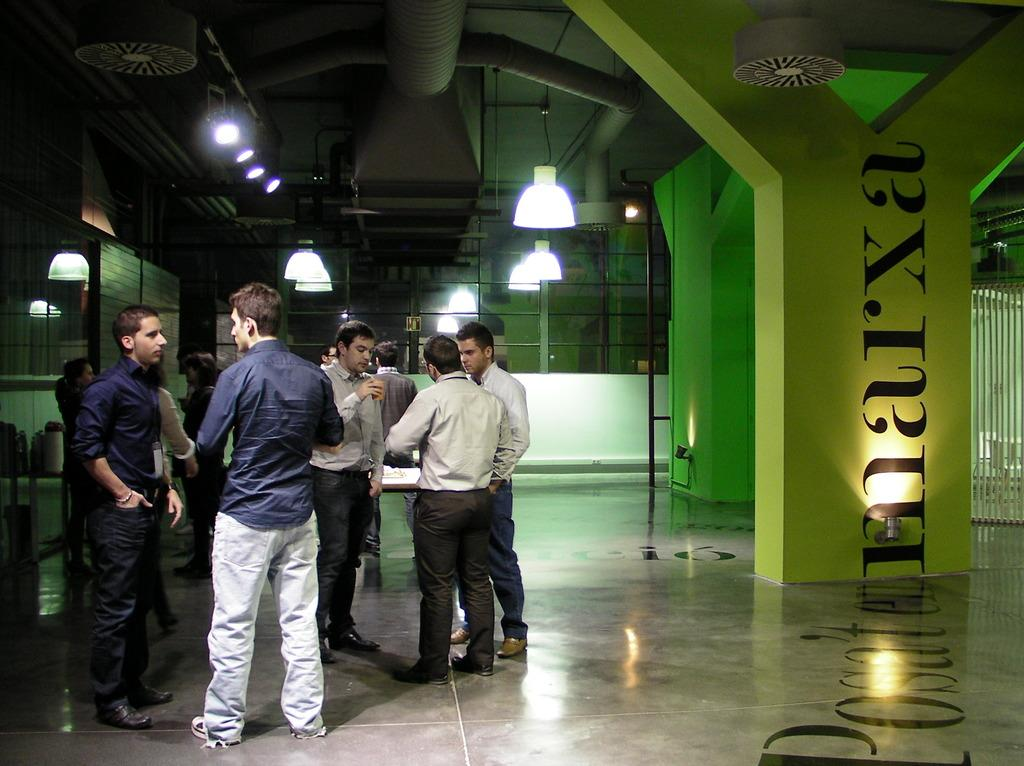What are the people in the image doing? The people in the image are standing on the floor. What architectural features can be seen in the image? There is a pillar and a pole in the image. What can be used for illumination in the image? There are lights in the image. What type of structure is visible in the image? There is a wall in the image. What can be used for carrying fluids in the image? There are pipes in the image. Are there any other objects present in the image besides the ones mentioned? Yes, there are other objects present in the image. What type of wound can be seen on the wall in the image? There is no wound present on the wall in the image. 